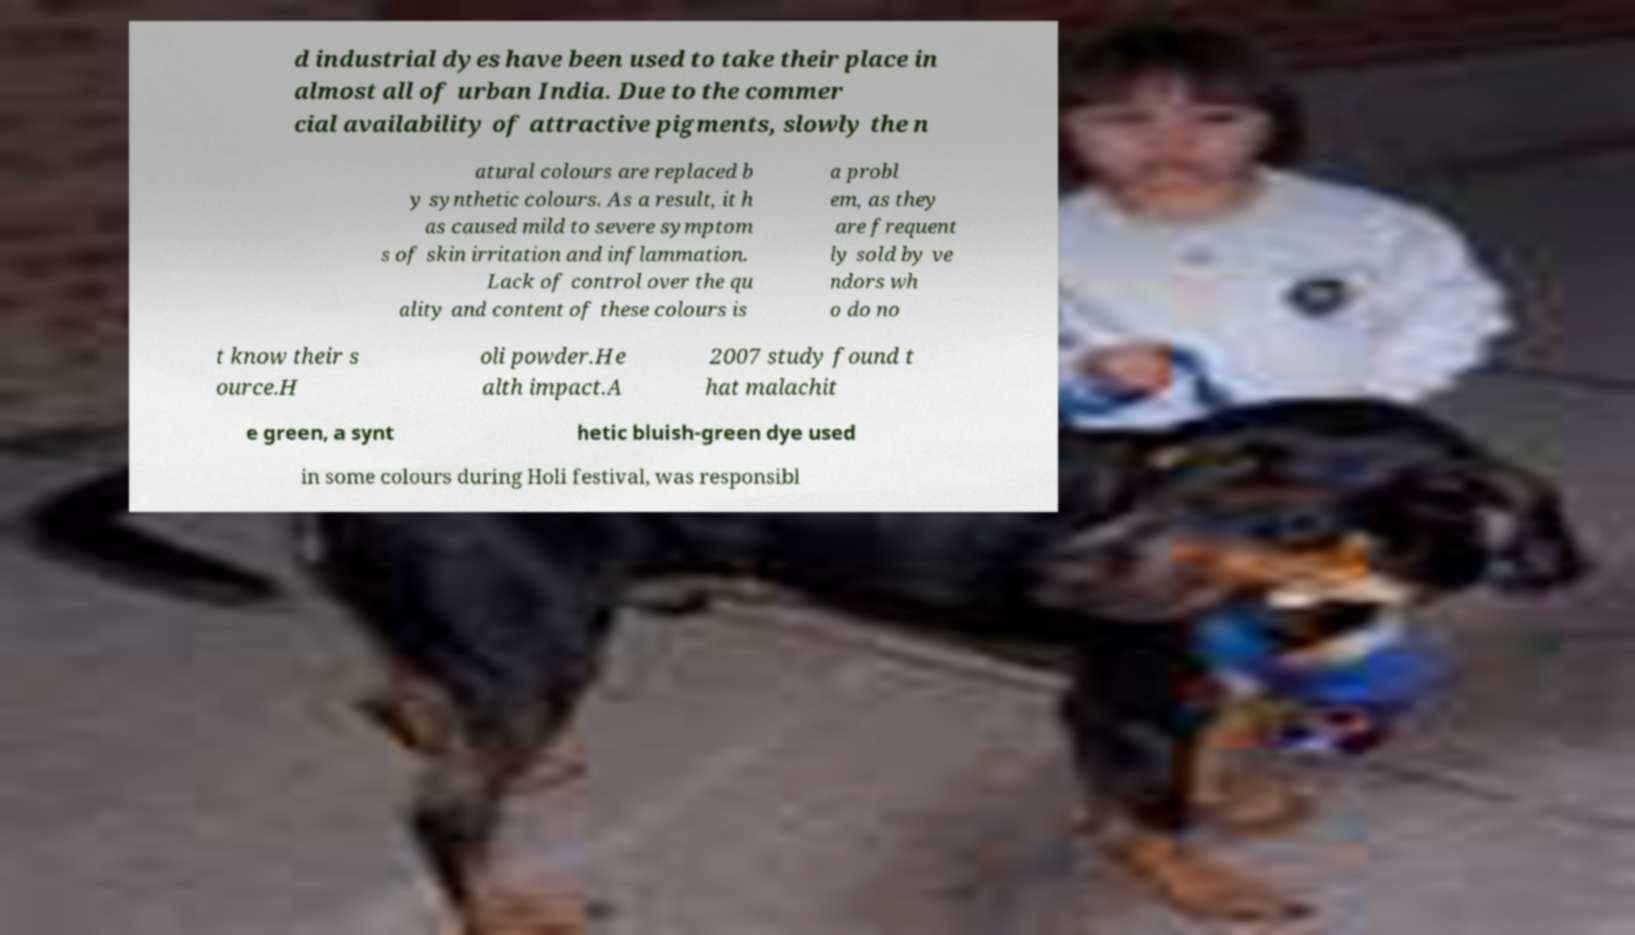Please identify and transcribe the text found in this image. d industrial dyes have been used to take their place in almost all of urban India. Due to the commer cial availability of attractive pigments, slowly the n atural colours are replaced b y synthetic colours. As a result, it h as caused mild to severe symptom s of skin irritation and inflammation. Lack of control over the qu ality and content of these colours is a probl em, as they are frequent ly sold by ve ndors wh o do no t know their s ource.H oli powder.He alth impact.A 2007 study found t hat malachit e green, a synt hetic bluish-green dye used in some colours during Holi festival, was responsibl 